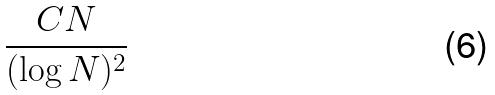<formula> <loc_0><loc_0><loc_500><loc_500>\frac { C N } { ( \log N ) ^ { 2 } }</formula> 